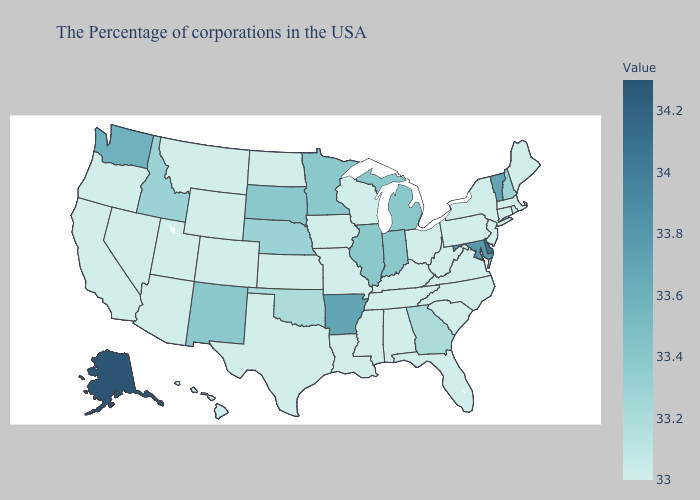Among the states that border New Mexico , does Utah have the highest value?
Concise answer only. No. Does Oklahoma have the lowest value in the USA?
Quick response, please. No. Which states hav the highest value in the Northeast?
Quick response, please. Vermont. Which states have the highest value in the USA?
Concise answer only. Alaska. 